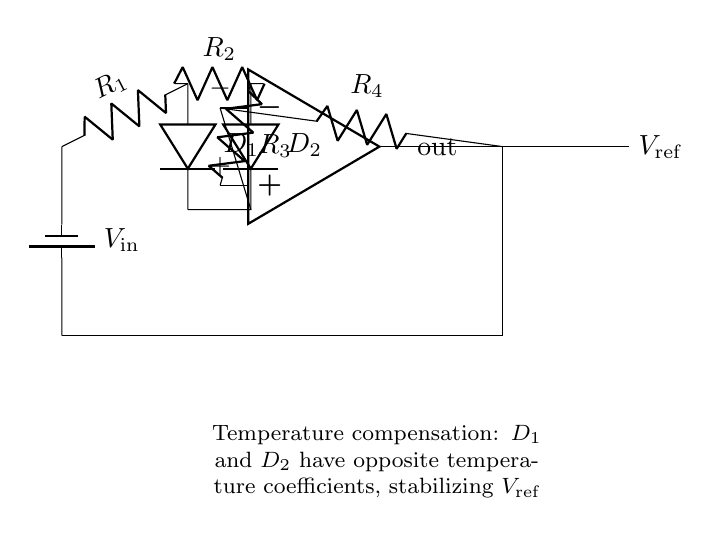What is the main function of the op-amp in this circuit? The op-amp functions as a voltage regulator, amplifying the difference between its input terminals to stabilize the reference voltage output.
Answer: Voltage regulator What type of diodes are used for temperature compensation? The circuit uses two temperature-sensitive diodes, specifically denoted as D1 and D2, which have opposite temperature coefficients.
Answer: D1 and D2 What is the purpose of resistor R3 in the circuit? Resistor R3 is used to set the gain of the op-amp and also influences the feedback loop, impacting the output reference voltage stability.
Answer: Set gain How do D1 and D2 contribute to temperature stability? D1 and D2 have been selected such that one conducts more current and the other conducts less as temperature changes, allowing them to offset temperature variations.
Answer: Offset variations What does the output voltage Vref represent? Vref represents the stable reference voltage that is generated by the op-amp and used for precise measurements in the circuit.
Answer: Stable reference voltage 